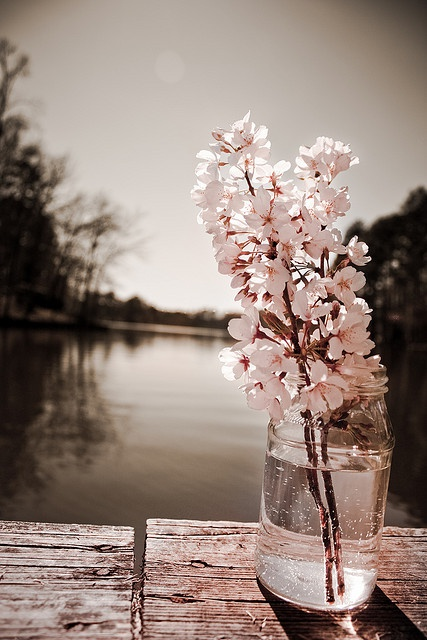Describe the objects in this image and their specific colors. I can see a vase in gray, darkgray, and lightgray tones in this image. 